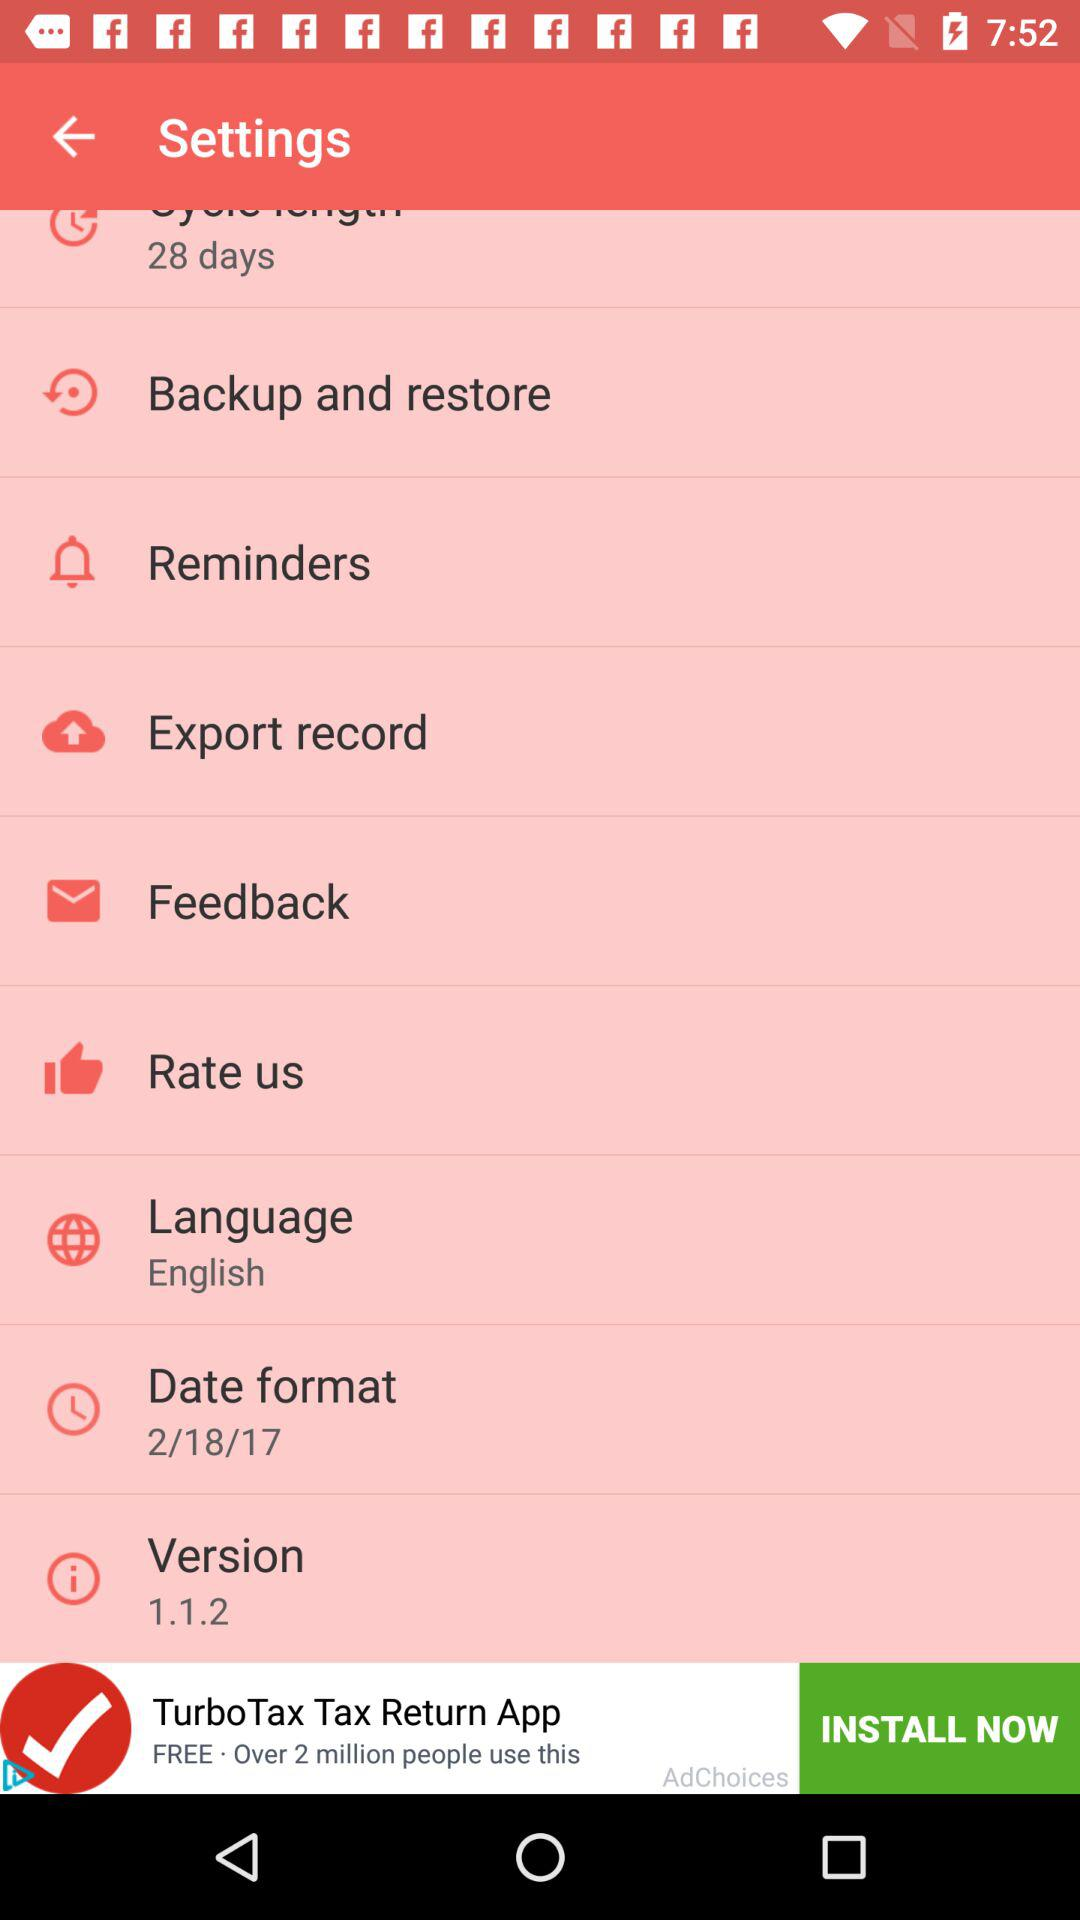What is the version of the application? The version is 1.1.2. 